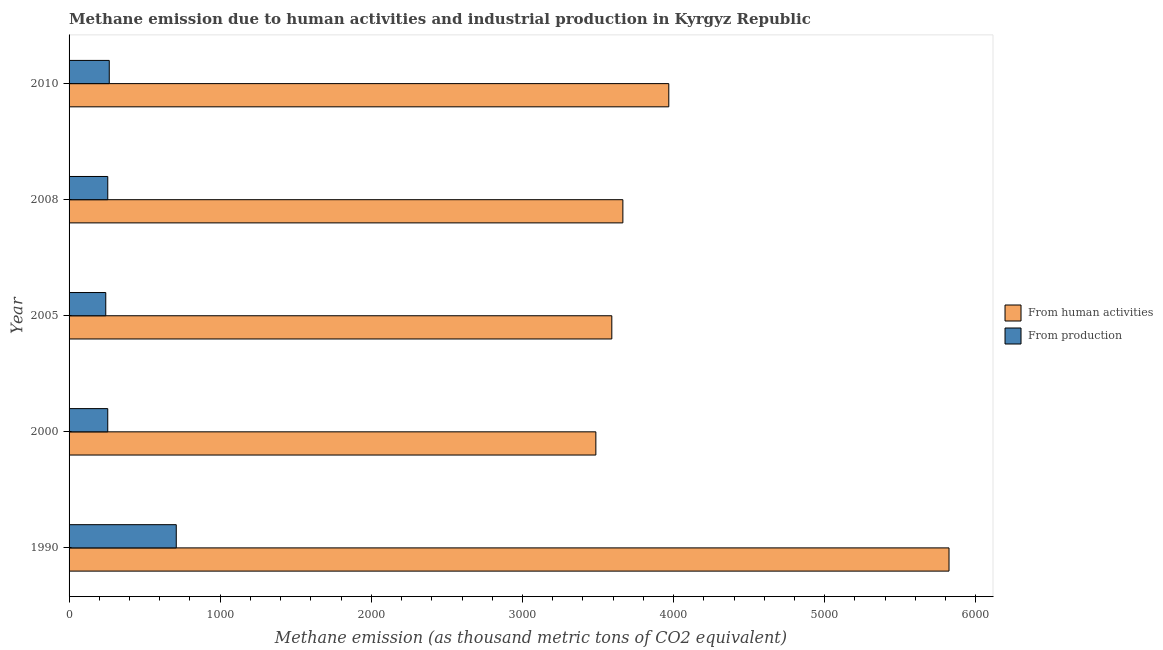Are the number of bars per tick equal to the number of legend labels?
Give a very brief answer. Yes. What is the label of the 5th group of bars from the top?
Give a very brief answer. 1990. What is the amount of emissions generated from industries in 2005?
Your response must be concise. 242.8. Across all years, what is the maximum amount of emissions from human activities?
Provide a short and direct response. 5822.6. Across all years, what is the minimum amount of emissions generated from industries?
Ensure brevity in your answer.  242.8. What is the total amount of emissions generated from industries in the graph?
Ensure brevity in your answer.  1730. What is the difference between the amount of emissions generated from industries in 2008 and that in 2010?
Provide a short and direct response. -10. What is the difference between the amount of emissions from human activities in 2005 and the amount of emissions generated from industries in 2010?
Your answer should be compact. 3325.3. What is the average amount of emissions from human activities per year?
Give a very brief answer. 4106.52. In the year 2000, what is the difference between the amount of emissions from human activities and amount of emissions generated from industries?
Your answer should be compact. 3229.9. What is the ratio of the amount of emissions generated from industries in 1990 to that in 2005?
Offer a terse response. 2.92. Is the amount of emissions from human activities in 1990 less than that in 2005?
Keep it short and to the point. No. Is the difference between the amount of emissions generated from industries in 2000 and 2005 greater than the difference between the amount of emissions from human activities in 2000 and 2005?
Your answer should be very brief. Yes. What is the difference between the highest and the second highest amount of emissions generated from industries?
Your answer should be compact. 443.3. What is the difference between the highest and the lowest amount of emissions from human activities?
Provide a short and direct response. 2336.8. In how many years, is the amount of emissions from human activities greater than the average amount of emissions from human activities taken over all years?
Keep it short and to the point. 1. What does the 1st bar from the top in 2005 represents?
Your answer should be very brief. From production. What does the 1st bar from the bottom in 2000 represents?
Offer a very short reply. From human activities. How many years are there in the graph?
Make the answer very short. 5. What is the difference between two consecutive major ticks on the X-axis?
Offer a very short reply. 1000. Are the values on the major ticks of X-axis written in scientific E-notation?
Offer a very short reply. No. Does the graph contain any zero values?
Make the answer very short. No. How many legend labels are there?
Give a very brief answer. 2. How are the legend labels stacked?
Provide a short and direct response. Vertical. What is the title of the graph?
Your answer should be compact. Methane emission due to human activities and industrial production in Kyrgyz Republic. What is the label or title of the X-axis?
Provide a short and direct response. Methane emission (as thousand metric tons of CO2 equivalent). What is the Methane emission (as thousand metric tons of CO2 equivalent) in From human activities in 1990?
Your response must be concise. 5822.6. What is the Methane emission (as thousand metric tons of CO2 equivalent) in From production in 1990?
Ensure brevity in your answer.  709.3. What is the Methane emission (as thousand metric tons of CO2 equivalent) of From human activities in 2000?
Keep it short and to the point. 3485.8. What is the Methane emission (as thousand metric tons of CO2 equivalent) of From production in 2000?
Offer a terse response. 255.9. What is the Methane emission (as thousand metric tons of CO2 equivalent) of From human activities in 2005?
Ensure brevity in your answer.  3591.3. What is the Methane emission (as thousand metric tons of CO2 equivalent) of From production in 2005?
Offer a terse response. 242.8. What is the Methane emission (as thousand metric tons of CO2 equivalent) of From human activities in 2008?
Your answer should be very brief. 3664.5. What is the Methane emission (as thousand metric tons of CO2 equivalent) in From production in 2008?
Provide a short and direct response. 256. What is the Methane emission (as thousand metric tons of CO2 equivalent) of From human activities in 2010?
Your answer should be very brief. 3968.4. What is the Methane emission (as thousand metric tons of CO2 equivalent) in From production in 2010?
Keep it short and to the point. 266. Across all years, what is the maximum Methane emission (as thousand metric tons of CO2 equivalent) of From human activities?
Make the answer very short. 5822.6. Across all years, what is the maximum Methane emission (as thousand metric tons of CO2 equivalent) in From production?
Your answer should be compact. 709.3. Across all years, what is the minimum Methane emission (as thousand metric tons of CO2 equivalent) of From human activities?
Keep it short and to the point. 3485.8. Across all years, what is the minimum Methane emission (as thousand metric tons of CO2 equivalent) of From production?
Offer a terse response. 242.8. What is the total Methane emission (as thousand metric tons of CO2 equivalent) in From human activities in the graph?
Provide a succinct answer. 2.05e+04. What is the total Methane emission (as thousand metric tons of CO2 equivalent) of From production in the graph?
Your response must be concise. 1730. What is the difference between the Methane emission (as thousand metric tons of CO2 equivalent) in From human activities in 1990 and that in 2000?
Offer a terse response. 2336.8. What is the difference between the Methane emission (as thousand metric tons of CO2 equivalent) in From production in 1990 and that in 2000?
Make the answer very short. 453.4. What is the difference between the Methane emission (as thousand metric tons of CO2 equivalent) of From human activities in 1990 and that in 2005?
Provide a short and direct response. 2231.3. What is the difference between the Methane emission (as thousand metric tons of CO2 equivalent) in From production in 1990 and that in 2005?
Your answer should be compact. 466.5. What is the difference between the Methane emission (as thousand metric tons of CO2 equivalent) of From human activities in 1990 and that in 2008?
Provide a short and direct response. 2158.1. What is the difference between the Methane emission (as thousand metric tons of CO2 equivalent) in From production in 1990 and that in 2008?
Provide a succinct answer. 453.3. What is the difference between the Methane emission (as thousand metric tons of CO2 equivalent) in From human activities in 1990 and that in 2010?
Make the answer very short. 1854.2. What is the difference between the Methane emission (as thousand metric tons of CO2 equivalent) of From production in 1990 and that in 2010?
Give a very brief answer. 443.3. What is the difference between the Methane emission (as thousand metric tons of CO2 equivalent) of From human activities in 2000 and that in 2005?
Keep it short and to the point. -105.5. What is the difference between the Methane emission (as thousand metric tons of CO2 equivalent) of From production in 2000 and that in 2005?
Ensure brevity in your answer.  13.1. What is the difference between the Methane emission (as thousand metric tons of CO2 equivalent) in From human activities in 2000 and that in 2008?
Ensure brevity in your answer.  -178.7. What is the difference between the Methane emission (as thousand metric tons of CO2 equivalent) of From production in 2000 and that in 2008?
Give a very brief answer. -0.1. What is the difference between the Methane emission (as thousand metric tons of CO2 equivalent) of From human activities in 2000 and that in 2010?
Your answer should be very brief. -482.6. What is the difference between the Methane emission (as thousand metric tons of CO2 equivalent) in From human activities in 2005 and that in 2008?
Your response must be concise. -73.2. What is the difference between the Methane emission (as thousand metric tons of CO2 equivalent) of From human activities in 2005 and that in 2010?
Your response must be concise. -377.1. What is the difference between the Methane emission (as thousand metric tons of CO2 equivalent) of From production in 2005 and that in 2010?
Your response must be concise. -23.2. What is the difference between the Methane emission (as thousand metric tons of CO2 equivalent) of From human activities in 2008 and that in 2010?
Offer a very short reply. -303.9. What is the difference between the Methane emission (as thousand metric tons of CO2 equivalent) of From production in 2008 and that in 2010?
Offer a very short reply. -10. What is the difference between the Methane emission (as thousand metric tons of CO2 equivalent) of From human activities in 1990 and the Methane emission (as thousand metric tons of CO2 equivalent) of From production in 2000?
Your answer should be compact. 5566.7. What is the difference between the Methane emission (as thousand metric tons of CO2 equivalent) of From human activities in 1990 and the Methane emission (as thousand metric tons of CO2 equivalent) of From production in 2005?
Your answer should be very brief. 5579.8. What is the difference between the Methane emission (as thousand metric tons of CO2 equivalent) in From human activities in 1990 and the Methane emission (as thousand metric tons of CO2 equivalent) in From production in 2008?
Ensure brevity in your answer.  5566.6. What is the difference between the Methane emission (as thousand metric tons of CO2 equivalent) of From human activities in 1990 and the Methane emission (as thousand metric tons of CO2 equivalent) of From production in 2010?
Your response must be concise. 5556.6. What is the difference between the Methane emission (as thousand metric tons of CO2 equivalent) in From human activities in 2000 and the Methane emission (as thousand metric tons of CO2 equivalent) in From production in 2005?
Ensure brevity in your answer.  3243. What is the difference between the Methane emission (as thousand metric tons of CO2 equivalent) of From human activities in 2000 and the Methane emission (as thousand metric tons of CO2 equivalent) of From production in 2008?
Your answer should be very brief. 3229.8. What is the difference between the Methane emission (as thousand metric tons of CO2 equivalent) in From human activities in 2000 and the Methane emission (as thousand metric tons of CO2 equivalent) in From production in 2010?
Give a very brief answer. 3219.8. What is the difference between the Methane emission (as thousand metric tons of CO2 equivalent) in From human activities in 2005 and the Methane emission (as thousand metric tons of CO2 equivalent) in From production in 2008?
Your answer should be very brief. 3335.3. What is the difference between the Methane emission (as thousand metric tons of CO2 equivalent) in From human activities in 2005 and the Methane emission (as thousand metric tons of CO2 equivalent) in From production in 2010?
Provide a succinct answer. 3325.3. What is the difference between the Methane emission (as thousand metric tons of CO2 equivalent) in From human activities in 2008 and the Methane emission (as thousand metric tons of CO2 equivalent) in From production in 2010?
Offer a very short reply. 3398.5. What is the average Methane emission (as thousand metric tons of CO2 equivalent) of From human activities per year?
Keep it short and to the point. 4106.52. What is the average Methane emission (as thousand metric tons of CO2 equivalent) in From production per year?
Make the answer very short. 346. In the year 1990, what is the difference between the Methane emission (as thousand metric tons of CO2 equivalent) of From human activities and Methane emission (as thousand metric tons of CO2 equivalent) of From production?
Keep it short and to the point. 5113.3. In the year 2000, what is the difference between the Methane emission (as thousand metric tons of CO2 equivalent) of From human activities and Methane emission (as thousand metric tons of CO2 equivalent) of From production?
Your answer should be compact. 3229.9. In the year 2005, what is the difference between the Methane emission (as thousand metric tons of CO2 equivalent) in From human activities and Methane emission (as thousand metric tons of CO2 equivalent) in From production?
Ensure brevity in your answer.  3348.5. In the year 2008, what is the difference between the Methane emission (as thousand metric tons of CO2 equivalent) of From human activities and Methane emission (as thousand metric tons of CO2 equivalent) of From production?
Your answer should be compact. 3408.5. In the year 2010, what is the difference between the Methane emission (as thousand metric tons of CO2 equivalent) in From human activities and Methane emission (as thousand metric tons of CO2 equivalent) in From production?
Offer a very short reply. 3702.4. What is the ratio of the Methane emission (as thousand metric tons of CO2 equivalent) of From human activities in 1990 to that in 2000?
Make the answer very short. 1.67. What is the ratio of the Methane emission (as thousand metric tons of CO2 equivalent) in From production in 1990 to that in 2000?
Provide a succinct answer. 2.77. What is the ratio of the Methane emission (as thousand metric tons of CO2 equivalent) of From human activities in 1990 to that in 2005?
Your answer should be compact. 1.62. What is the ratio of the Methane emission (as thousand metric tons of CO2 equivalent) of From production in 1990 to that in 2005?
Your answer should be compact. 2.92. What is the ratio of the Methane emission (as thousand metric tons of CO2 equivalent) of From human activities in 1990 to that in 2008?
Make the answer very short. 1.59. What is the ratio of the Methane emission (as thousand metric tons of CO2 equivalent) of From production in 1990 to that in 2008?
Keep it short and to the point. 2.77. What is the ratio of the Methane emission (as thousand metric tons of CO2 equivalent) in From human activities in 1990 to that in 2010?
Keep it short and to the point. 1.47. What is the ratio of the Methane emission (as thousand metric tons of CO2 equivalent) in From production in 1990 to that in 2010?
Offer a very short reply. 2.67. What is the ratio of the Methane emission (as thousand metric tons of CO2 equivalent) in From human activities in 2000 to that in 2005?
Offer a terse response. 0.97. What is the ratio of the Methane emission (as thousand metric tons of CO2 equivalent) in From production in 2000 to that in 2005?
Offer a terse response. 1.05. What is the ratio of the Methane emission (as thousand metric tons of CO2 equivalent) of From human activities in 2000 to that in 2008?
Provide a short and direct response. 0.95. What is the ratio of the Methane emission (as thousand metric tons of CO2 equivalent) of From human activities in 2000 to that in 2010?
Offer a very short reply. 0.88. What is the ratio of the Methane emission (as thousand metric tons of CO2 equivalent) in From production in 2005 to that in 2008?
Your answer should be compact. 0.95. What is the ratio of the Methane emission (as thousand metric tons of CO2 equivalent) in From human activities in 2005 to that in 2010?
Your answer should be compact. 0.91. What is the ratio of the Methane emission (as thousand metric tons of CO2 equivalent) in From production in 2005 to that in 2010?
Keep it short and to the point. 0.91. What is the ratio of the Methane emission (as thousand metric tons of CO2 equivalent) of From human activities in 2008 to that in 2010?
Offer a very short reply. 0.92. What is the ratio of the Methane emission (as thousand metric tons of CO2 equivalent) of From production in 2008 to that in 2010?
Provide a short and direct response. 0.96. What is the difference between the highest and the second highest Methane emission (as thousand metric tons of CO2 equivalent) in From human activities?
Provide a short and direct response. 1854.2. What is the difference between the highest and the second highest Methane emission (as thousand metric tons of CO2 equivalent) in From production?
Your answer should be very brief. 443.3. What is the difference between the highest and the lowest Methane emission (as thousand metric tons of CO2 equivalent) in From human activities?
Your answer should be very brief. 2336.8. What is the difference between the highest and the lowest Methane emission (as thousand metric tons of CO2 equivalent) of From production?
Provide a short and direct response. 466.5. 